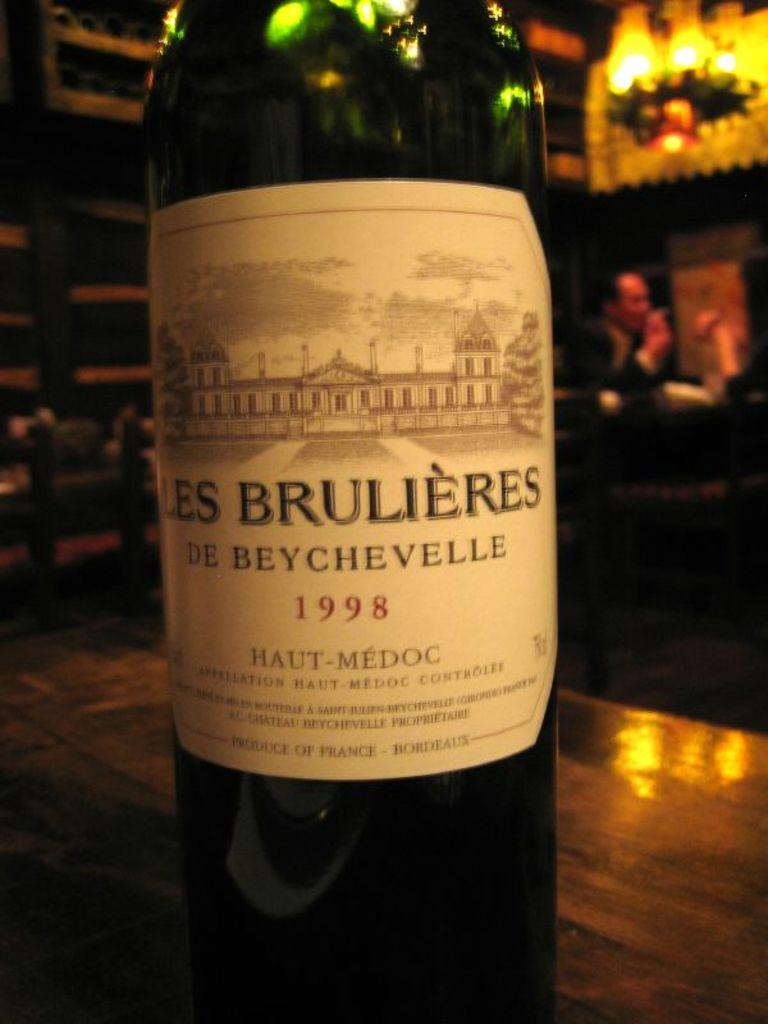Provide a one-sentence caption for the provided image. A bottle of French wine made in the year 1998. 